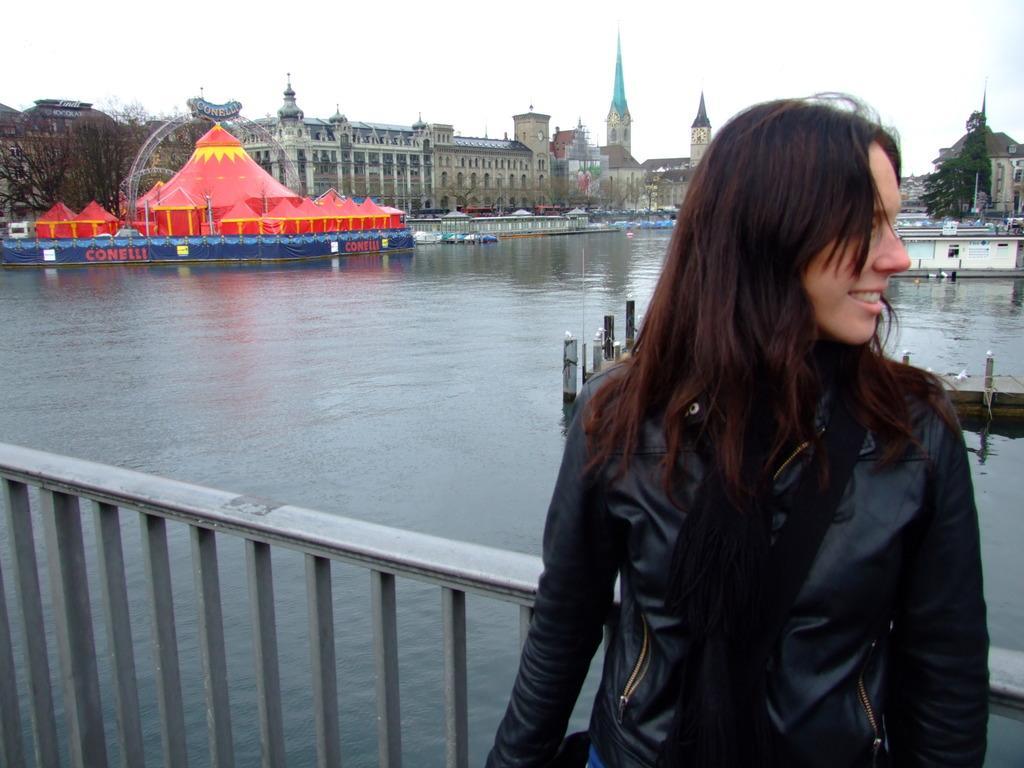Can you describe this image briefly? In front of the image there is a woman, behind the woman there is a metal rod fence, behind the fence there is water. On the water there are boats and wooden platform. On the other side of the water, there are tents, trees, buildings and some other objects. 